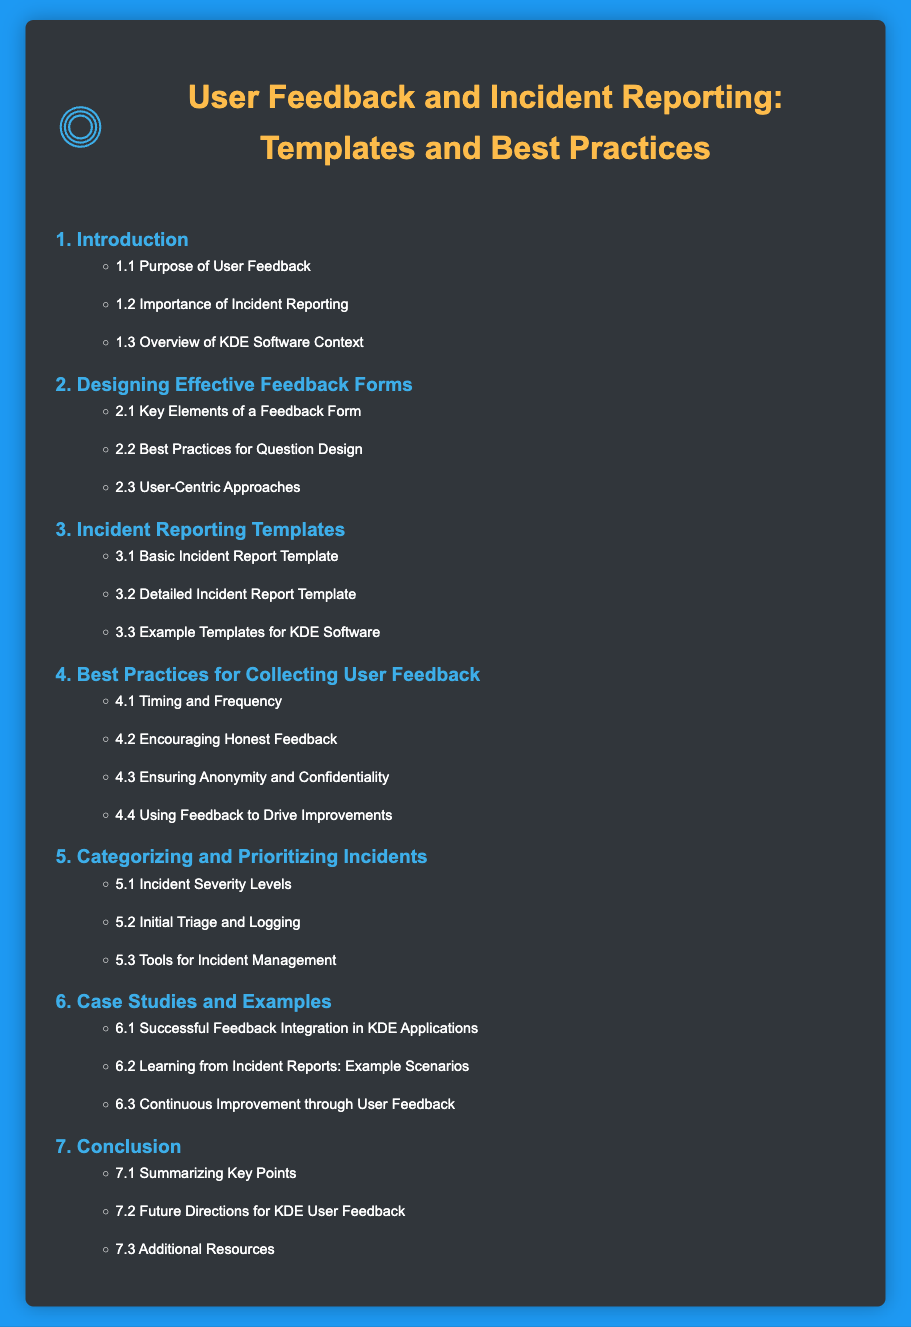what is the title of the document? The title of the document is specified at the top, indicating its main focus.
Answer: User Feedback and Incident Reporting: Templates and Best Practices how many main sections are in the table of contents? The number of main sections listed in the table of contents represents the primary topics addressed in the document.
Answer: 7 what is the first subsection under Introduction? The first subsection provides specific details about the purpose of user feedback.
Answer: Purpose of User Feedback what is the focus of section 4? Section 4 emphasizes strategies for effectively gathering user input and assessments.
Answer: Best Practices for Collecting User Feedback which section contains example templates for KDE software? This section specifically discusses templates designed with KDE software context in mind.
Answer: Incident Reporting Templates what does section 5 discuss in relation to incidents? Section 5 outlines methods for assessing and organizing reported incidents.
Answer: Categorizing and Prioritizing Incidents what is the last subsection in the document? The last subsection summarizes key points discussed throughout the document while providing future outlooks.
Answer: Additional Resources how many subsections are there in section 3? The count of subsections reflects the depth of content in the section about incident reporting templates.
Answer: 3 